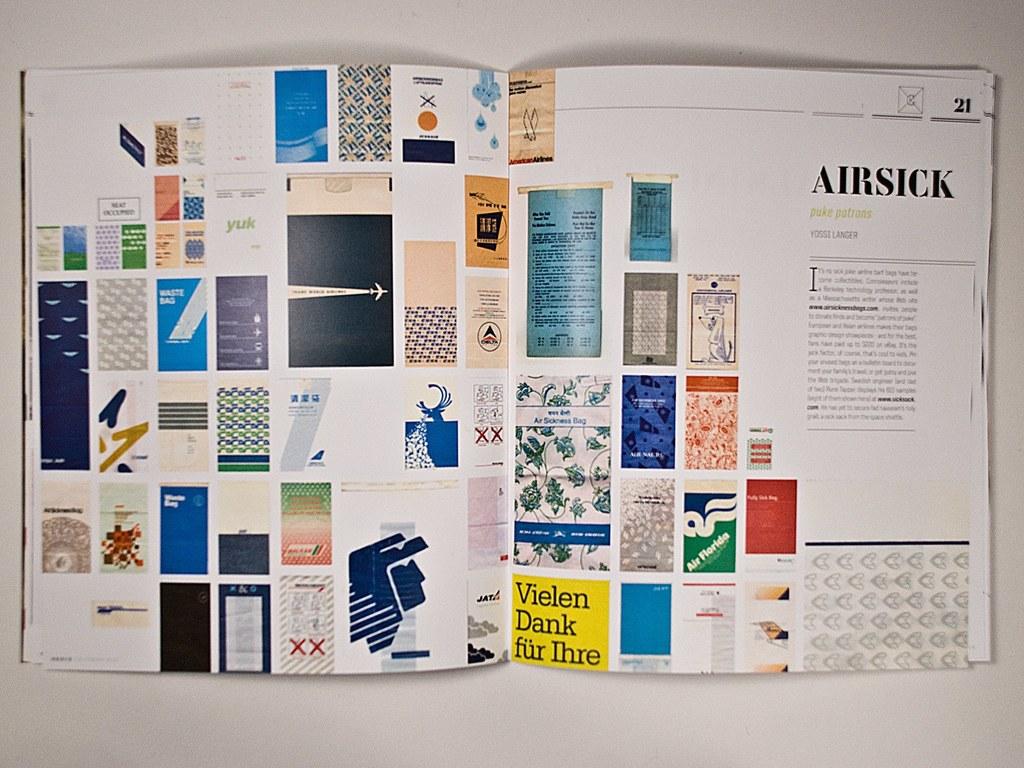What is the book's title?
Your answer should be very brief. Airsick. 